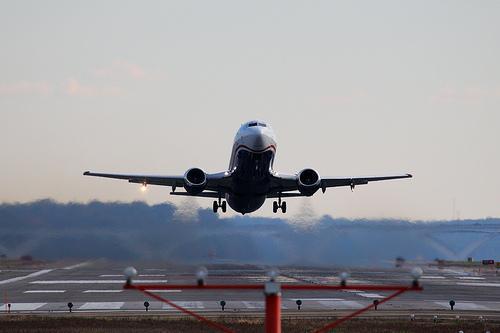How many planes are there?
Give a very brief answer. 1. 